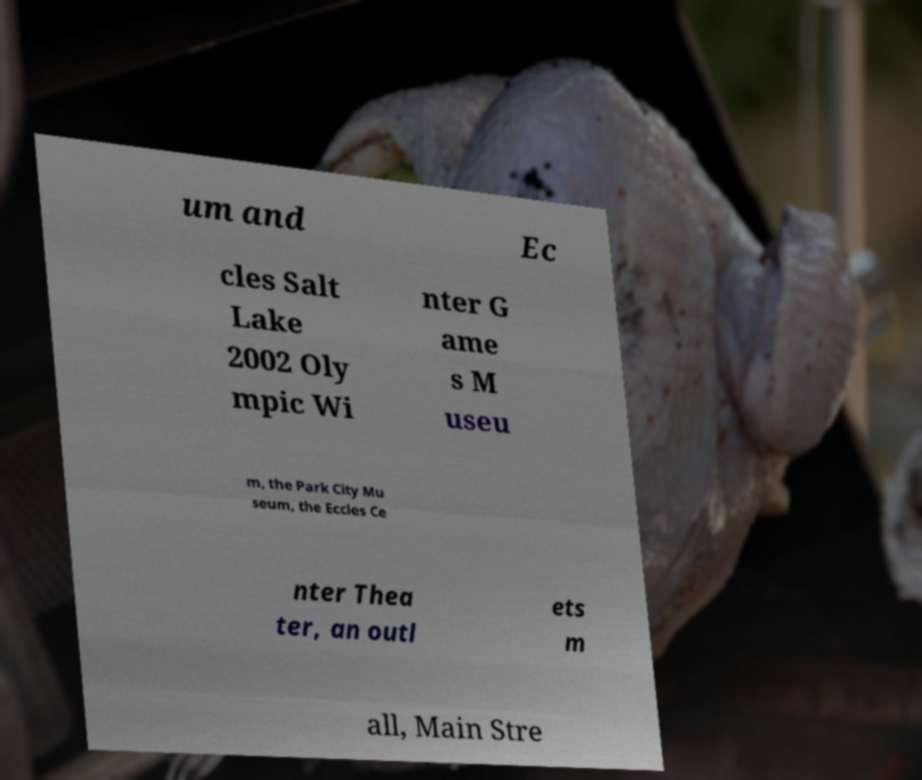Can you accurately transcribe the text from the provided image for me? um and Ec cles Salt Lake 2002 Oly mpic Wi nter G ame s M useu m, the Park City Mu seum, the Eccles Ce nter Thea ter, an outl ets m all, Main Stre 